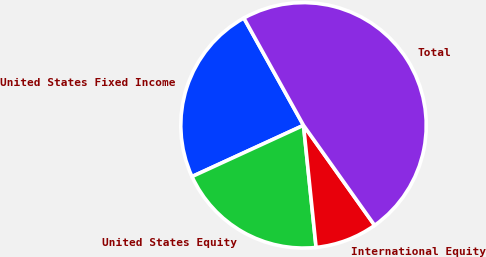Convert chart to OTSL. <chart><loc_0><loc_0><loc_500><loc_500><pie_chart><fcel>United States Fixed Income<fcel>United States Equity<fcel>International Equity<fcel>Total<nl><fcel>23.78%<fcel>19.78%<fcel>8.2%<fcel>48.24%<nl></chart> 